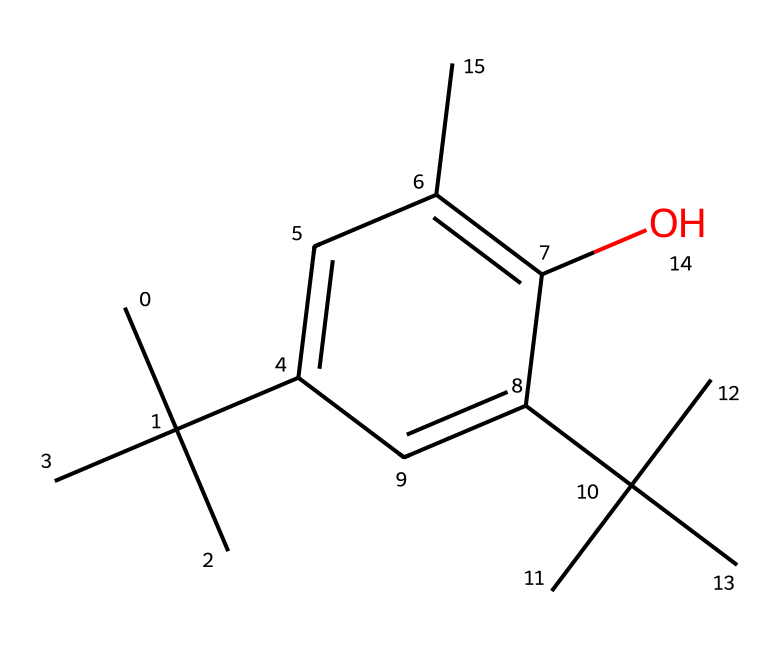What is the name of this compound? The shown structure corresponds to butylated hydroxytoluene, commonly abbreviated as BHT, which is a well-known phenolic antioxidant.
Answer: butylated hydroxytoluene How many carbon atoms are present in BHT? Analyzing the SMILES string, we can count the carbon atoms. There are 16 carbon atoms indicated in the structure.
Answer: 16 How many hydroxyl (–OH) groups are present? In the structure, there is one hydroxyl group indicated by the "O" bonded to a carbon atom.
Answer: 1 What type of chemical bond connects the carbon and oxygen atoms in the hydroxyl group? The connection between the carbon and oxygen in the hydroxyl group is a single covalent bond (the single bond represented in the SMILES).
Answer: single covalent How many phenolic rings are present in the structure? BHT contains one phenolic ring, which can be identified by the distinct aromatic structure with alternating double bonds in the cyclic portion of the SMILES representation.
Answer: 1 What is the significance of BHT in cleaning products? BHT acts as a phenol-based antioxidant that prevents oxidation and degradation of other components in cleaning products, enhancing their stability and shelf life.
Answer: antioxidant 